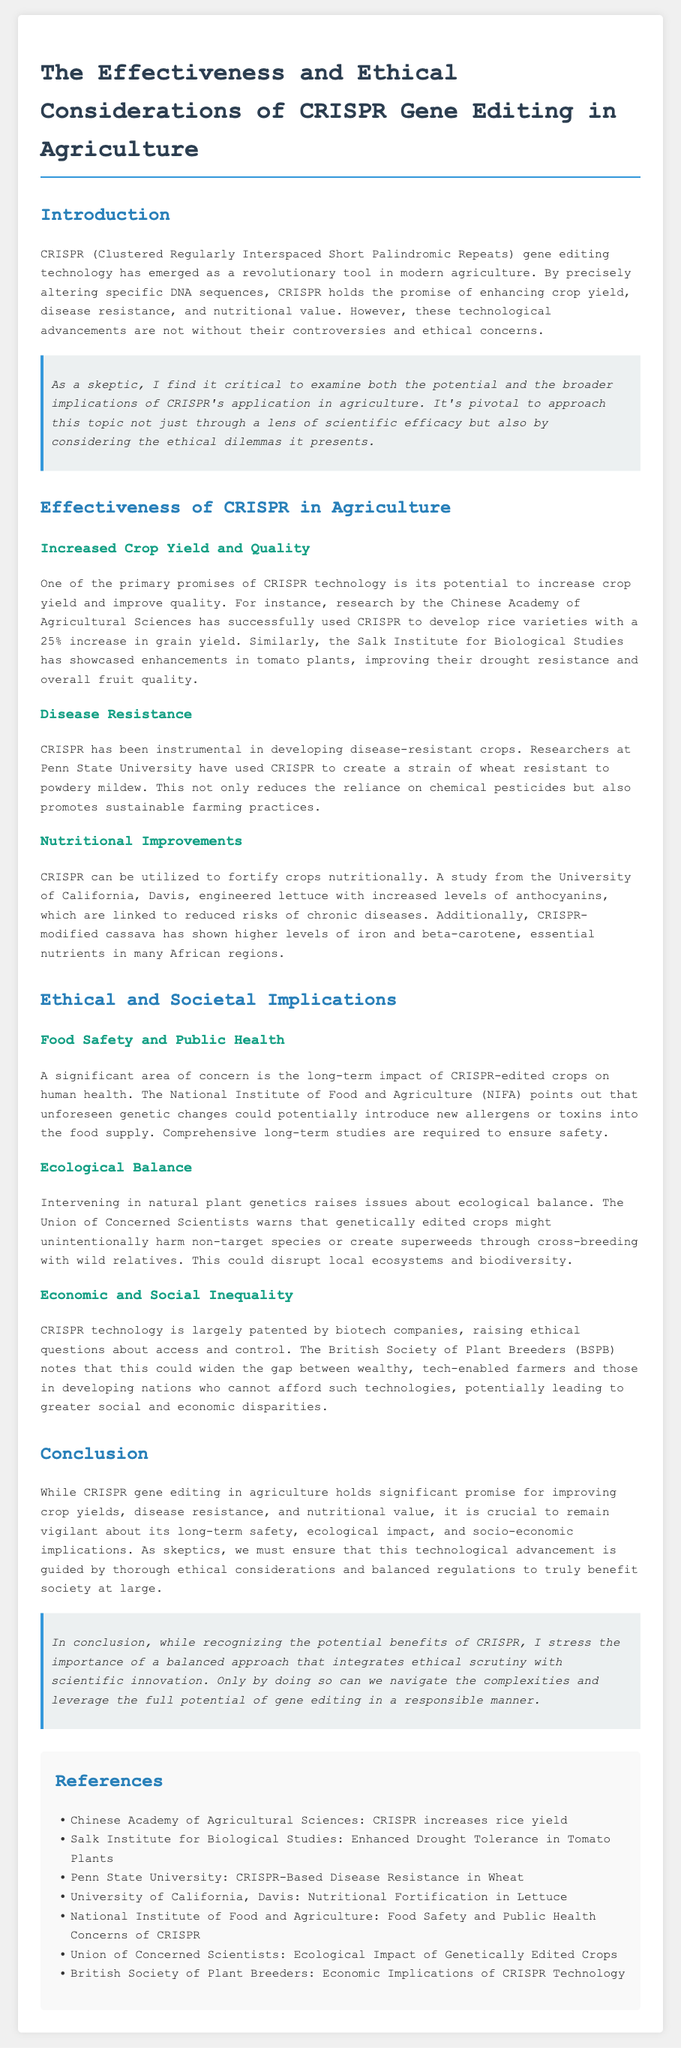What is CRISPR technology? CRISPR is described as a revolutionary tool in modern agriculture that allows for precise alteration of DNA sequences.
Answer: A revolutionary tool in modern agriculture What percentage increase in grain yield has CRISPR achieved in rice varieties? The document states that CRISPR has developed rice varieties with a 25% increase in grain yield.
Answer: 25% Which institution developed a strain of wheat resistant to powdery mildew? The document specifies that Penn State University has created this strain using CRISPR technology.
Answer: Penn State University What ecological concern is raised regarding CRISPR-edited crops? It discusses the potential for genetically edited crops to unintentionally harm non-target species.
Answer: Harm non-target species What nutritional improvement was made in lettuce using CRISPR? The University of California, Davis, increased levels of anthocyanins in lettuce through CRISPR.
Answer: Increased levels of anthocyanins According to the British Society of Plant Breeders, what ethical issue does CRISPR technology raise? The ethical issue highlighted is related to access and control of patented technology, which could widen the gap between different farmers.
Answer: Access and control What is a necessary step mentioned for ensuring food safety with CRISPR-edited crops? The document calls for comprehensive long-term studies to ensure safety before these crops are widely adopted.
Answer: Comprehensive long-term studies What is one potential benefit of CRISPR technology in agriculture mentioned in this report? Increased crop yields, disease resistance, and nutritional value are noted as potential benefits.
Answer: Increased crop yields What does the report suggest is essential for the application of CRISPR in agriculture? The conclusion emphasizes the need for thorough ethical considerations and balanced regulations.
Answer: Thorough ethical considerations 